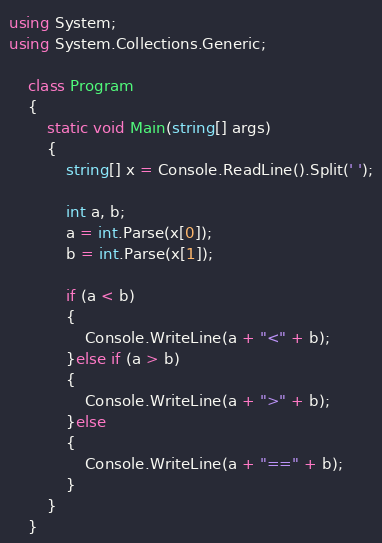<code> <loc_0><loc_0><loc_500><loc_500><_C#_>using System;
using System.Collections.Generic;

    class Program
    {
        static void Main(string[] args)
        {
            string[] x = Console.ReadLine().Split(' ');

            int a, b;
            a = int.Parse(x[0]);
            b = int.Parse(x[1]);

            if (a < b)
            {
                Console.WriteLine(a + "<" + b);
            }else if (a > b)
            {
                Console.WriteLine(a + ">" + b);
            }else
            {
                Console.WriteLine(a + "==" + b);
            }
        }
    }

</code> 